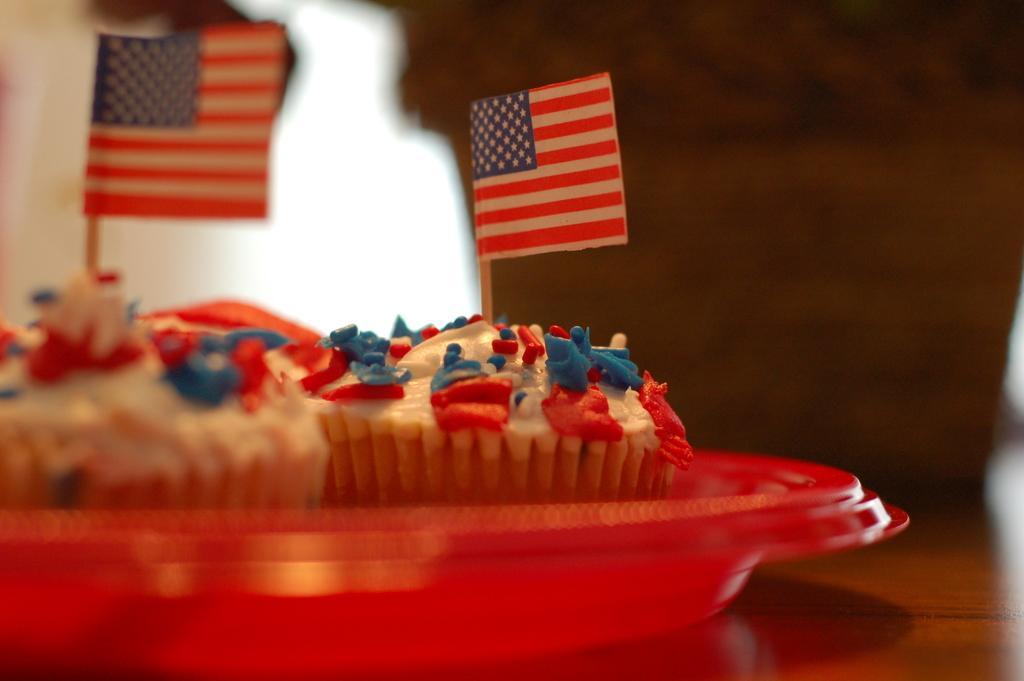In one or two sentences, can you explain what this image depicts? In this image there are cupcakes in a plate which was placed on the table. There are two flags and the background of the image is blur. 